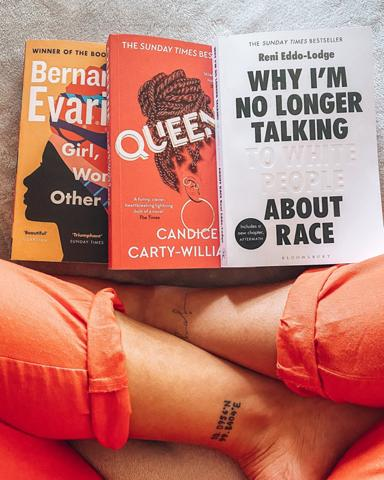What achievement do the books share according to the image? Both books, as identified on their covers, share the prestigious achievement of being recognized as Sunday Times bestsellers, indicating their widespread acclaim and popularity. 